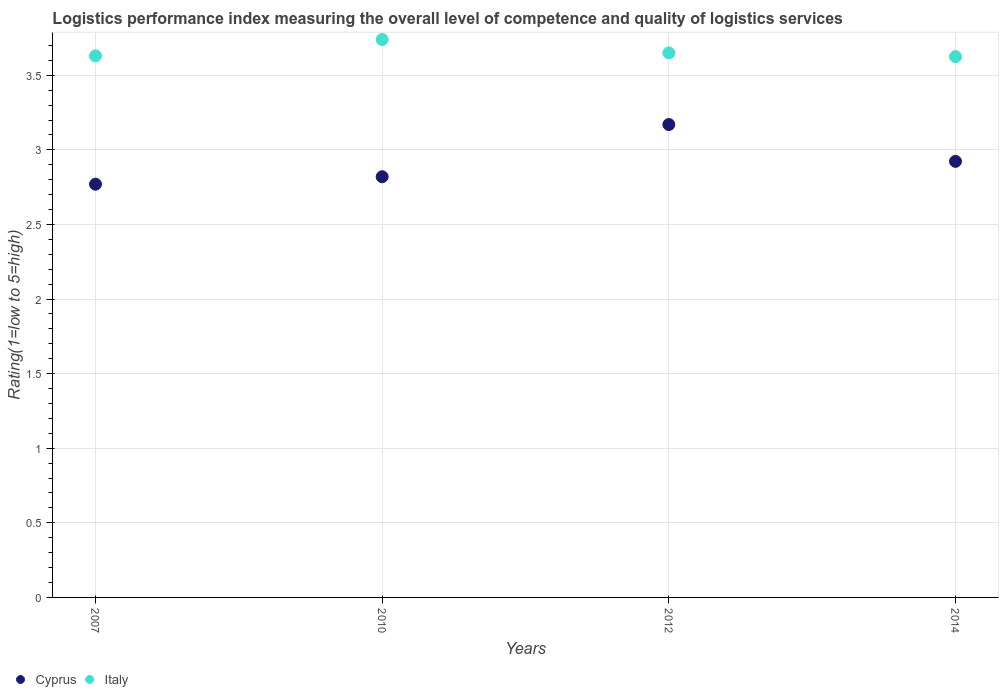What is the Logistic performance index in Italy in 2012?
Keep it short and to the point. 3.65. Across all years, what is the maximum Logistic performance index in Italy?
Ensure brevity in your answer.  3.74. Across all years, what is the minimum Logistic performance index in Italy?
Offer a very short reply. 3.62. In which year was the Logistic performance index in Italy minimum?
Ensure brevity in your answer.  2014. What is the total Logistic performance index in Italy in the graph?
Ensure brevity in your answer.  14.64. What is the difference between the Logistic performance index in Cyprus in 2007 and that in 2014?
Provide a short and direct response. -0.15. What is the difference between the Logistic performance index in Cyprus in 2014 and the Logistic performance index in Italy in 2012?
Your answer should be very brief. -0.73. What is the average Logistic performance index in Cyprus per year?
Ensure brevity in your answer.  2.92. In the year 2014, what is the difference between the Logistic performance index in Cyprus and Logistic performance index in Italy?
Ensure brevity in your answer.  -0.7. In how many years, is the Logistic performance index in Cyprus greater than 0.7?
Make the answer very short. 4. What is the ratio of the Logistic performance index in Italy in 2007 to that in 2010?
Provide a succinct answer. 0.97. What is the difference between the highest and the second highest Logistic performance index in Italy?
Keep it short and to the point. 0.09. What is the difference between the highest and the lowest Logistic performance index in Cyprus?
Offer a very short reply. 0.4. In how many years, is the Logistic performance index in Cyprus greater than the average Logistic performance index in Cyprus taken over all years?
Offer a very short reply. 2. Does the Logistic performance index in Cyprus monotonically increase over the years?
Provide a short and direct response. No. Is the Logistic performance index in Cyprus strictly less than the Logistic performance index in Italy over the years?
Offer a very short reply. Yes. How many dotlines are there?
Ensure brevity in your answer.  2. Are the values on the major ticks of Y-axis written in scientific E-notation?
Keep it short and to the point. No. Where does the legend appear in the graph?
Ensure brevity in your answer.  Bottom left. What is the title of the graph?
Give a very brief answer. Logistics performance index measuring the overall level of competence and quality of logistics services. What is the label or title of the Y-axis?
Keep it short and to the point. Rating(1=low to 5=high). What is the Rating(1=low to 5=high) of Cyprus in 2007?
Your response must be concise. 2.77. What is the Rating(1=low to 5=high) of Italy in 2007?
Your response must be concise. 3.63. What is the Rating(1=low to 5=high) in Cyprus in 2010?
Ensure brevity in your answer.  2.82. What is the Rating(1=low to 5=high) of Italy in 2010?
Your answer should be very brief. 3.74. What is the Rating(1=low to 5=high) of Cyprus in 2012?
Keep it short and to the point. 3.17. What is the Rating(1=low to 5=high) in Italy in 2012?
Offer a terse response. 3.65. What is the Rating(1=low to 5=high) of Cyprus in 2014?
Ensure brevity in your answer.  2.92. What is the Rating(1=low to 5=high) of Italy in 2014?
Keep it short and to the point. 3.62. Across all years, what is the maximum Rating(1=low to 5=high) in Cyprus?
Offer a terse response. 3.17. Across all years, what is the maximum Rating(1=low to 5=high) in Italy?
Provide a short and direct response. 3.74. Across all years, what is the minimum Rating(1=low to 5=high) of Cyprus?
Offer a very short reply. 2.77. Across all years, what is the minimum Rating(1=low to 5=high) in Italy?
Ensure brevity in your answer.  3.62. What is the total Rating(1=low to 5=high) in Cyprus in the graph?
Provide a short and direct response. 11.68. What is the total Rating(1=low to 5=high) in Italy in the graph?
Provide a succinct answer. 14.64. What is the difference between the Rating(1=low to 5=high) in Italy in 2007 and that in 2010?
Offer a very short reply. -0.11. What is the difference between the Rating(1=low to 5=high) of Italy in 2007 and that in 2012?
Provide a succinct answer. -0.02. What is the difference between the Rating(1=low to 5=high) of Cyprus in 2007 and that in 2014?
Offer a very short reply. -0.15. What is the difference between the Rating(1=low to 5=high) in Italy in 2007 and that in 2014?
Offer a very short reply. 0.01. What is the difference between the Rating(1=low to 5=high) in Cyprus in 2010 and that in 2012?
Offer a terse response. -0.35. What is the difference between the Rating(1=low to 5=high) of Italy in 2010 and that in 2012?
Provide a short and direct response. 0.09. What is the difference between the Rating(1=low to 5=high) of Cyprus in 2010 and that in 2014?
Ensure brevity in your answer.  -0.1. What is the difference between the Rating(1=low to 5=high) of Italy in 2010 and that in 2014?
Your answer should be very brief. 0.12. What is the difference between the Rating(1=low to 5=high) in Cyprus in 2012 and that in 2014?
Offer a very short reply. 0.25. What is the difference between the Rating(1=low to 5=high) of Italy in 2012 and that in 2014?
Your response must be concise. 0.03. What is the difference between the Rating(1=low to 5=high) in Cyprus in 2007 and the Rating(1=low to 5=high) in Italy in 2010?
Provide a short and direct response. -0.97. What is the difference between the Rating(1=low to 5=high) in Cyprus in 2007 and the Rating(1=low to 5=high) in Italy in 2012?
Your response must be concise. -0.88. What is the difference between the Rating(1=low to 5=high) in Cyprus in 2007 and the Rating(1=low to 5=high) in Italy in 2014?
Provide a short and direct response. -0.85. What is the difference between the Rating(1=low to 5=high) in Cyprus in 2010 and the Rating(1=low to 5=high) in Italy in 2012?
Offer a terse response. -0.83. What is the difference between the Rating(1=low to 5=high) in Cyprus in 2010 and the Rating(1=low to 5=high) in Italy in 2014?
Your response must be concise. -0.81. What is the difference between the Rating(1=low to 5=high) of Cyprus in 2012 and the Rating(1=low to 5=high) of Italy in 2014?
Your answer should be compact. -0.46. What is the average Rating(1=low to 5=high) in Cyprus per year?
Give a very brief answer. 2.92. What is the average Rating(1=low to 5=high) of Italy per year?
Offer a very short reply. 3.66. In the year 2007, what is the difference between the Rating(1=low to 5=high) of Cyprus and Rating(1=low to 5=high) of Italy?
Keep it short and to the point. -0.86. In the year 2010, what is the difference between the Rating(1=low to 5=high) in Cyprus and Rating(1=low to 5=high) in Italy?
Provide a succinct answer. -0.92. In the year 2012, what is the difference between the Rating(1=low to 5=high) of Cyprus and Rating(1=low to 5=high) of Italy?
Keep it short and to the point. -0.48. In the year 2014, what is the difference between the Rating(1=low to 5=high) in Cyprus and Rating(1=low to 5=high) in Italy?
Ensure brevity in your answer.  -0.7. What is the ratio of the Rating(1=low to 5=high) of Cyprus in 2007 to that in 2010?
Your answer should be very brief. 0.98. What is the ratio of the Rating(1=low to 5=high) of Italy in 2007 to that in 2010?
Keep it short and to the point. 0.97. What is the ratio of the Rating(1=low to 5=high) of Cyprus in 2007 to that in 2012?
Give a very brief answer. 0.87. What is the ratio of the Rating(1=low to 5=high) in Italy in 2007 to that in 2012?
Make the answer very short. 0.99. What is the ratio of the Rating(1=low to 5=high) in Cyprus in 2007 to that in 2014?
Your response must be concise. 0.95. What is the ratio of the Rating(1=low to 5=high) of Italy in 2007 to that in 2014?
Provide a succinct answer. 1. What is the ratio of the Rating(1=low to 5=high) of Cyprus in 2010 to that in 2012?
Provide a short and direct response. 0.89. What is the ratio of the Rating(1=low to 5=high) in Italy in 2010 to that in 2012?
Offer a very short reply. 1.02. What is the ratio of the Rating(1=low to 5=high) in Cyprus in 2010 to that in 2014?
Your answer should be very brief. 0.96. What is the ratio of the Rating(1=low to 5=high) of Italy in 2010 to that in 2014?
Offer a very short reply. 1.03. What is the ratio of the Rating(1=low to 5=high) of Cyprus in 2012 to that in 2014?
Keep it short and to the point. 1.08. What is the ratio of the Rating(1=low to 5=high) of Italy in 2012 to that in 2014?
Give a very brief answer. 1.01. What is the difference between the highest and the second highest Rating(1=low to 5=high) of Cyprus?
Your response must be concise. 0.25. What is the difference between the highest and the second highest Rating(1=low to 5=high) in Italy?
Your answer should be very brief. 0.09. What is the difference between the highest and the lowest Rating(1=low to 5=high) in Italy?
Give a very brief answer. 0.12. 